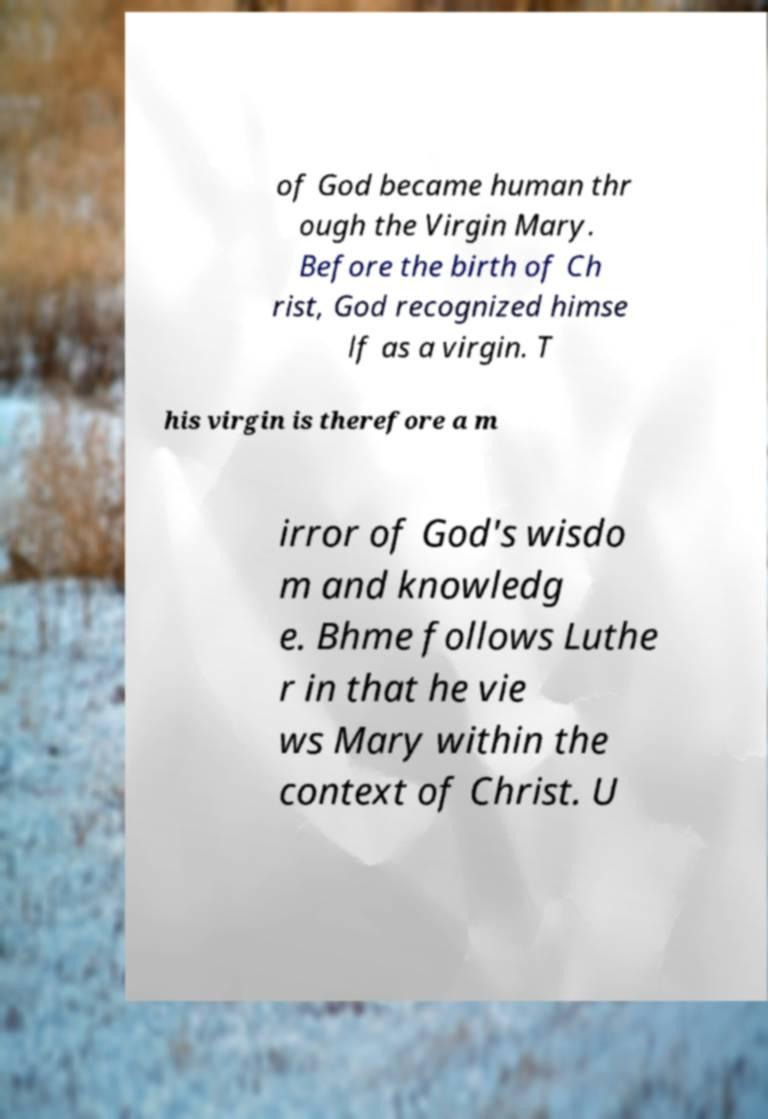There's text embedded in this image that I need extracted. Can you transcribe it verbatim? of God became human thr ough the Virgin Mary. Before the birth of Ch rist, God recognized himse lf as a virgin. T his virgin is therefore a m irror of God's wisdo m and knowledg e. Bhme follows Luthe r in that he vie ws Mary within the context of Christ. U 